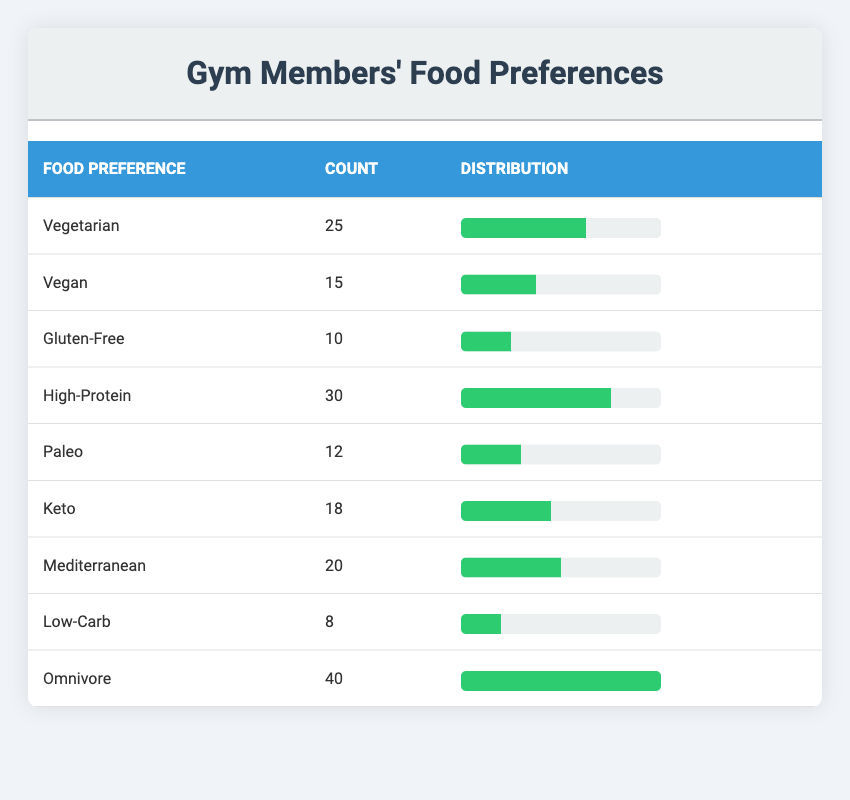What is the most popular food preference among gym members? The food preference with the highest count in the table is "Omnivore," with 40 members selecting this option.
Answer: Omnivore How many members prefer High-Protein? Referring directly to the table, the count for "High-Protein" is listed as 30.
Answer: 30 What is the combined count of members who prefer Vegetarian and Vegan? To find this, we add the counts for both categories: 25 (Vegetarian) + 15 (Vegan) = 40.
Answer: 40 Is the number of members preferring Low-Carb greater than those preferring Gluten-Free? The table shows 8 members for Low-Carb and 10 for Gluten-Free. Since 8 is less than 10, the statement is false.
Answer: No What percentage of members prefer Vegetarian? To calculate this percentage, divide the count of Vegetarian (25) by the total count of all members, which is 25 + 15 + 10 + 30 + 12 + 18 + 20 + 8 + 40 = 168. Then multiply by 100: (25/168) * 100 ≈ 14.88%.
Answer: 14.88% Among the dietary preferences listed, which has the least number of members? The table indicates that "Low-Carb" has the lowest count of 8, making it the least preferred option.
Answer: Low-Carb What is the average count of members across all food preferences? To find the average, sum all member counts: 25 + 15 + 10 + 30 + 12 + 18 + 20 + 8 + 40 = 168. There are 9 food preferences in total. Therefore, 168 / 9 ≈ 18.67.
Answer: 18.67 If a new member joins preferring Paleo, what will be the total count for that preference? The current count for Paleo is 12. Adding one new member would result in 12 + 1 = 13 members preferring Paleo.
Answer: 13 What are the total counts for members who prefer diets that are not vegetarian or vegan? The relevant categories are High-Protein (30), Paleo (12), Keto (18), Mediterranean (20), Low-Carb (8), and Omnivore (40). Summing these gives 30 + 12 + 18 + 20 + 8 + 40 = 128.
Answer: 128 